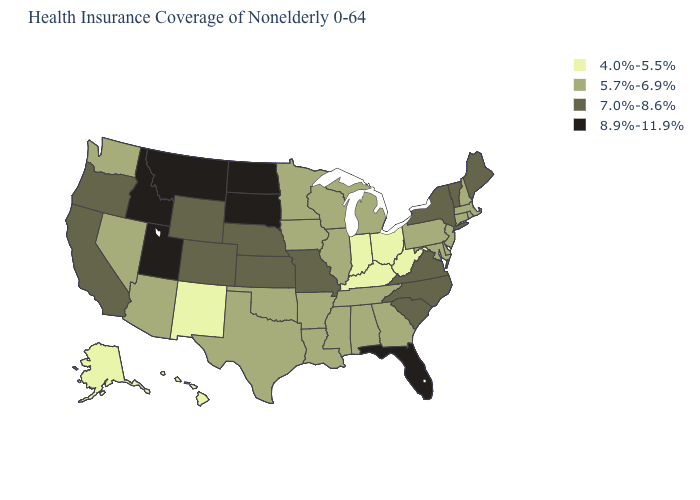What is the highest value in the USA?
Answer briefly. 8.9%-11.9%. What is the value of South Carolina?
Short answer required. 7.0%-8.6%. Among the states that border Vermont , which have the lowest value?
Answer briefly. Massachusetts, New Hampshire. Which states have the highest value in the USA?
Short answer required. Florida, Idaho, Montana, North Dakota, South Dakota, Utah. Among the states that border South Carolina , which have the highest value?
Answer briefly. North Carolina. What is the value of Florida?
Quick response, please. 8.9%-11.9%. What is the value of Pennsylvania?
Answer briefly. 5.7%-6.9%. What is the value of Washington?
Quick response, please. 5.7%-6.9%. Does New Jersey have the lowest value in the Northeast?
Quick response, please. Yes. Does Montana have the highest value in the USA?
Be succinct. Yes. Does Connecticut have the lowest value in the Northeast?
Short answer required. Yes. What is the value of Arizona?
Give a very brief answer. 5.7%-6.9%. What is the highest value in the USA?
Write a very short answer. 8.9%-11.9%. What is the lowest value in the Northeast?
Answer briefly. 5.7%-6.9%. What is the highest value in the USA?
Short answer required. 8.9%-11.9%. 